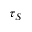Convert formula to latex. <formula><loc_0><loc_0><loc_500><loc_500>\tau _ { S }</formula> 